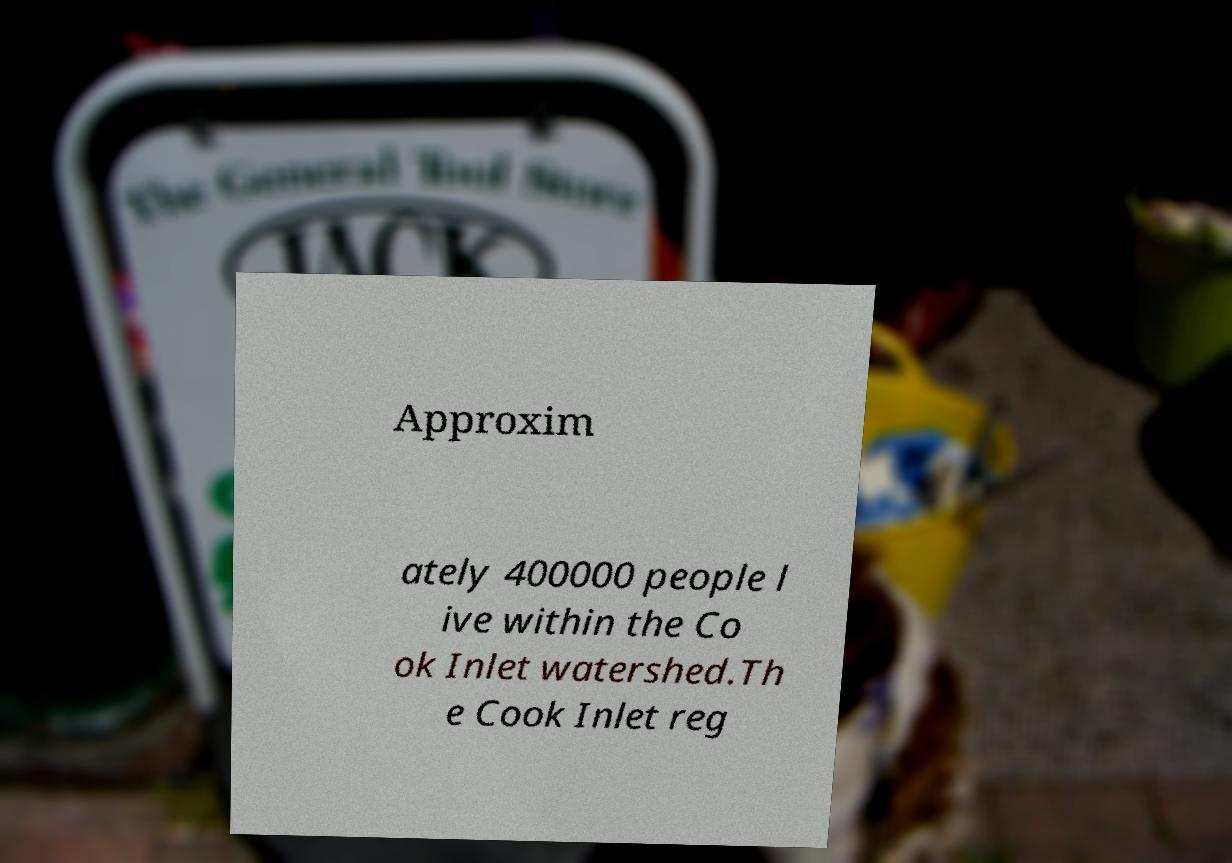Can you read and provide the text displayed in the image?This photo seems to have some interesting text. Can you extract and type it out for me? Approxim ately 400000 people l ive within the Co ok Inlet watershed.Th e Cook Inlet reg 